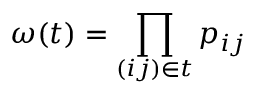<formula> <loc_0><loc_0><loc_500><loc_500>\omega ( t ) = \prod _ { ( i j ) \in t } p _ { i j }</formula> 